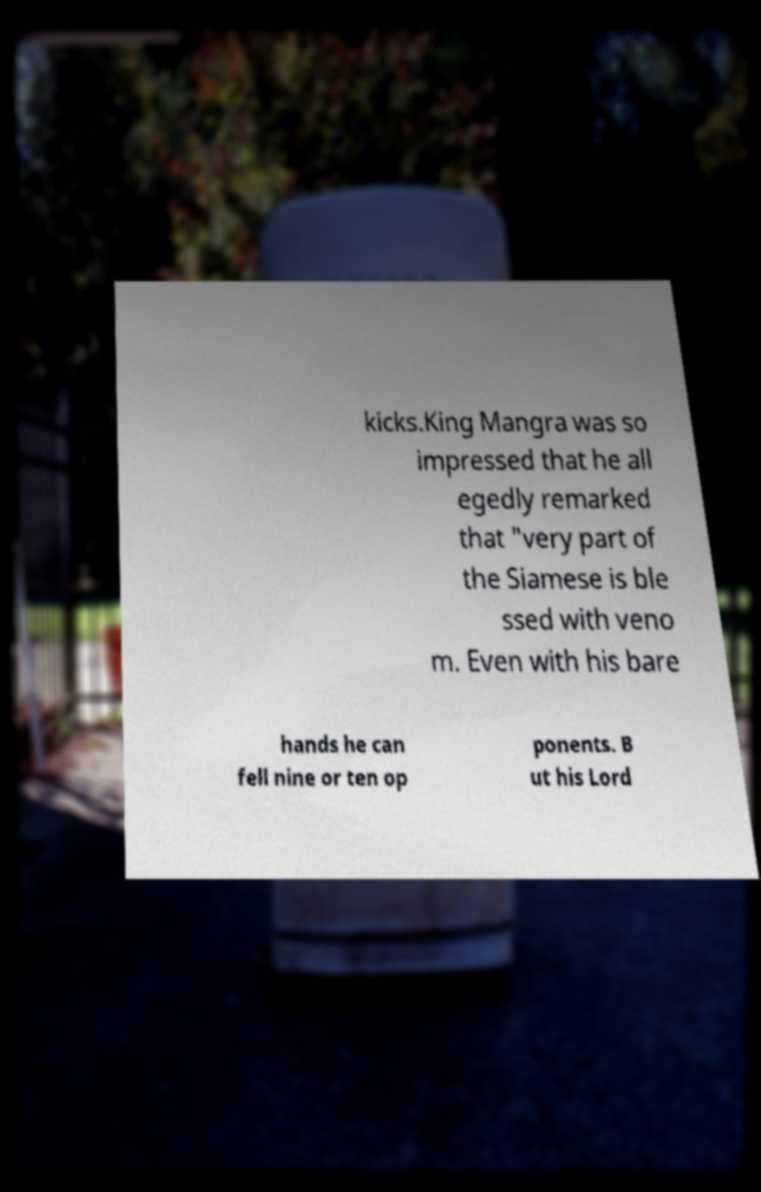I need the written content from this picture converted into text. Can you do that? kicks.King Mangra was so impressed that he all egedly remarked that "very part of the Siamese is ble ssed with veno m. Even with his bare hands he can fell nine or ten op ponents. B ut his Lord 